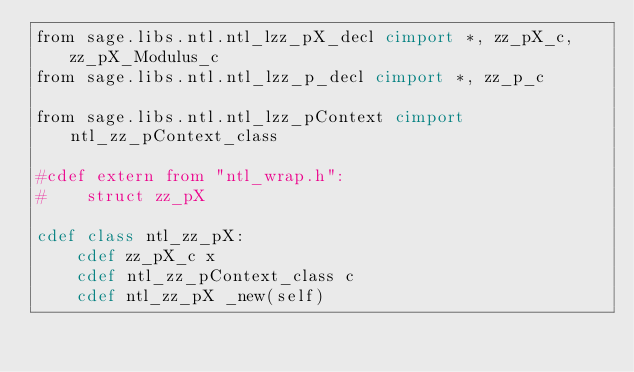Convert code to text. <code><loc_0><loc_0><loc_500><loc_500><_Cython_>from sage.libs.ntl.ntl_lzz_pX_decl cimport *, zz_pX_c, zz_pX_Modulus_c
from sage.libs.ntl.ntl_lzz_p_decl cimport *, zz_p_c

from sage.libs.ntl.ntl_lzz_pContext cimport ntl_zz_pContext_class

#cdef extern from "ntl_wrap.h":
#    struct zz_pX

cdef class ntl_zz_pX:
    cdef zz_pX_c x
    cdef ntl_zz_pContext_class c
    cdef ntl_zz_pX _new(self)


</code> 